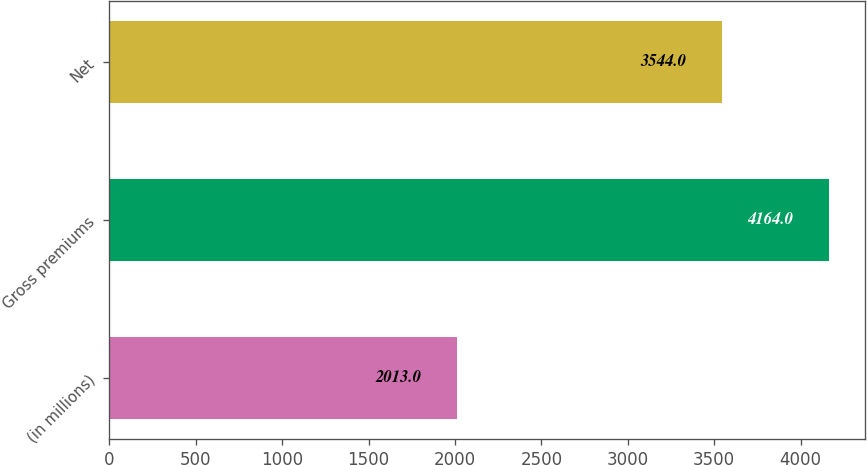Convert chart to OTSL. <chart><loc_0><loc_0><loc_500><loc_500><bar_chart><fcel>(in millions)<fcel>Gross premiums<fcel>Net<nl><fcel>2013<fcel>4164<fcel>3544<nl></chart> 